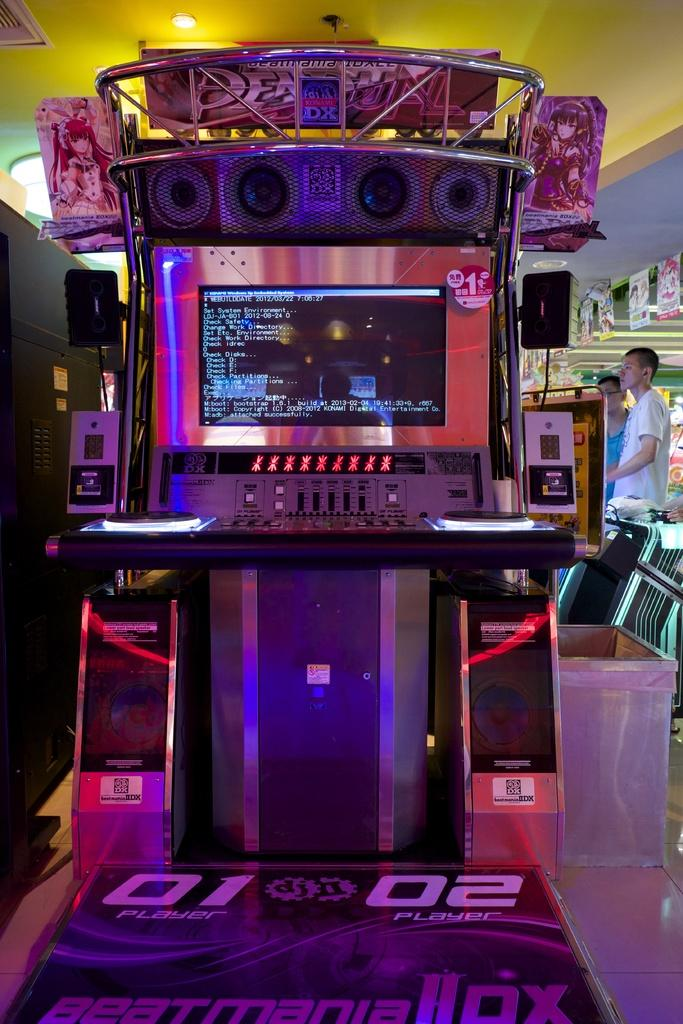What is located on the floor in the image? There is a machine on the floor in the image. What can be seen in the background of the image? There are two people, posters, lights, the ceiling, and some objects visible in the background of the image. What type of trees can be seen in the image? There are no trees present in the image. How does the pain affect the people in the image? There is no indication of pain or any individuals experiencing pain in the image. 